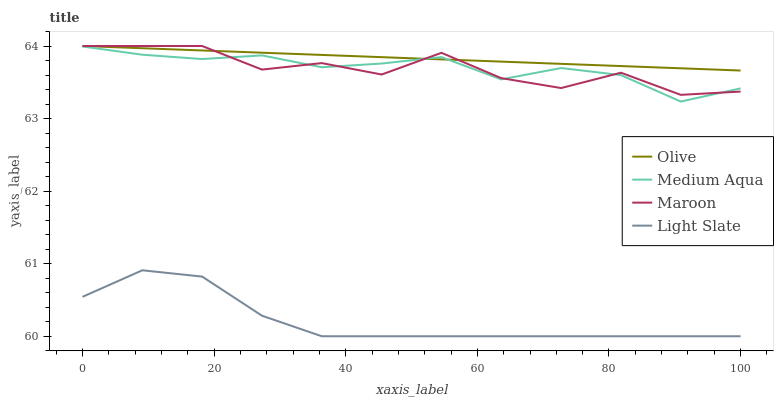Does Light Slate have the minimum area under the curve?
Answer yes or no. Yes. Does Olive have the maximum area under the curve?
Answer yes or no. Yes. Does Medium Aqua have the minimum area under the curve?
Answer yes or no. No. Does Medium Aqua have the maximum area under the curve?
Answer yes or no. No. Is Olive the smoothest?
Answer yes or no. Yes. Is Maroon the roughest?
Answer yes or no. Yes. Is Light Slate the smoothest?
Answer yes or no. No. Is Light Slate the roughest?
Answer yes or no. No. Does Light Slate have the lowest value?
Answer yes or no. Yes. Does Medium Aqua have the lowest value?
Answer yes or no. No. Does Maroon have the highest value?
Answer yes or no. Yes. Does Medium Aqua have the highest value?
Answer yes or no. No. Is Light Slate less than Medium Aqua?
Answer yes or no. Yes. Is Olive greater than Light Slate?
Answer yes or no. Yes. Does Medium Aqua intersect Maroon?
Answer yes or no. Yes. Is Medium Aqua less than Maroon?
Answer yes or no. No. Is Medium Aqua greater than Maroon?
Answer yes or no. No. Does Light Slate intersect Medium Aqua?
Answer yes or no. No. 